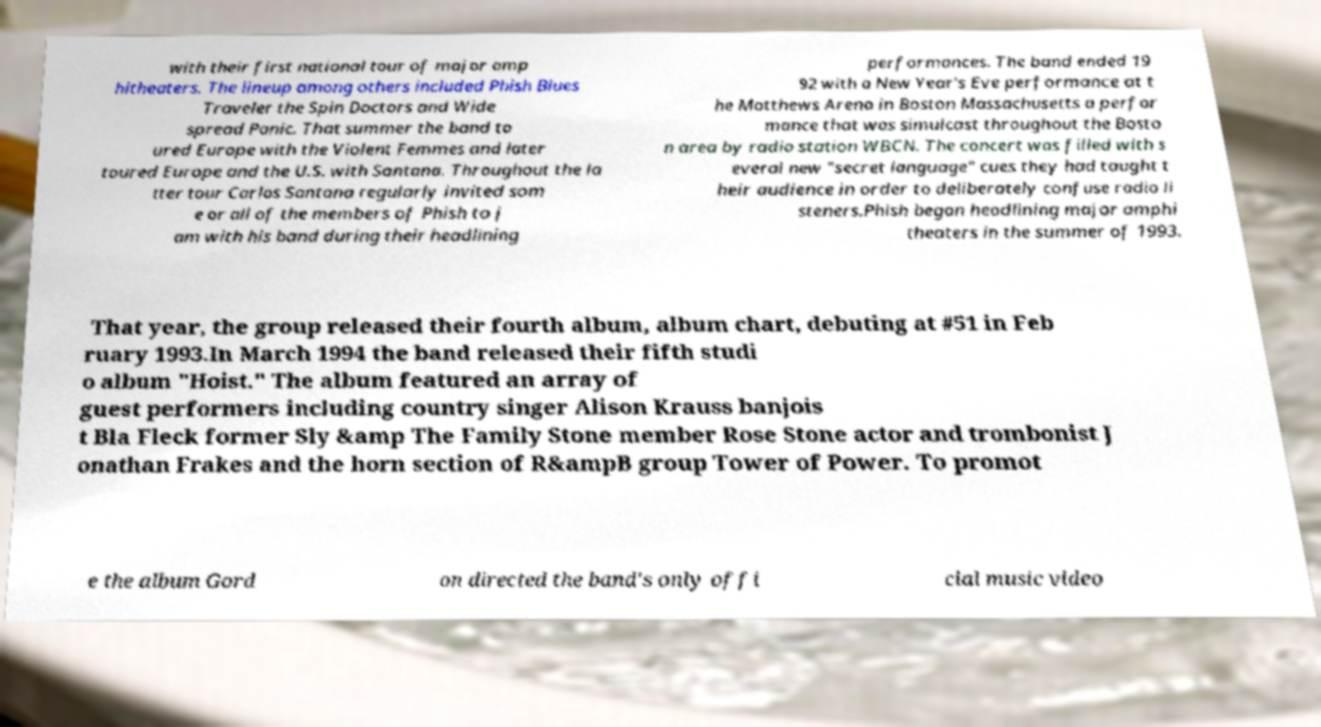Can you accurately transcribe the text from the provided image for me? with their first national tour of major amp hitheaters. The lineup among others included Phish Blues Traveler the Spin Doctors and Wide spread Panic. That summer the band to ured Europe with the Violent Femmes and later toured Europe and the U.S. with Santana. Throughout the la tter tour Carlos Santana regularly invited som e or all of the members of Phish to j am with his band during their headlining performances. The band ended 19 92 with a New Year's Eve performance at t he Matthews Arena in Boston Massachusetts a perfor mance that was simulcast throughout the Bosto n area by radio station WBCN. The concert was filled with s everal new "secret language" cues they had taught t heir audience in order to deliberately confuse radio li steners.Phish began headlining major amphi theaters in the summer of 1993. That year, the group released their fourth album, album chart, debuting at #51 in Feb ruary 1993.In March 1994 the band released their fifth studi o album "Hoist." The album featured an array of guest performers including country singer Alison Krauss banjois t Bla Fleck former Sly &amp The Family Stone member Rose Stone actor and trombonist J onathan Frakes and the horn section of R&ampB group Tower of Power. To promot e the album Gord on directed the band's only offi cial music video 